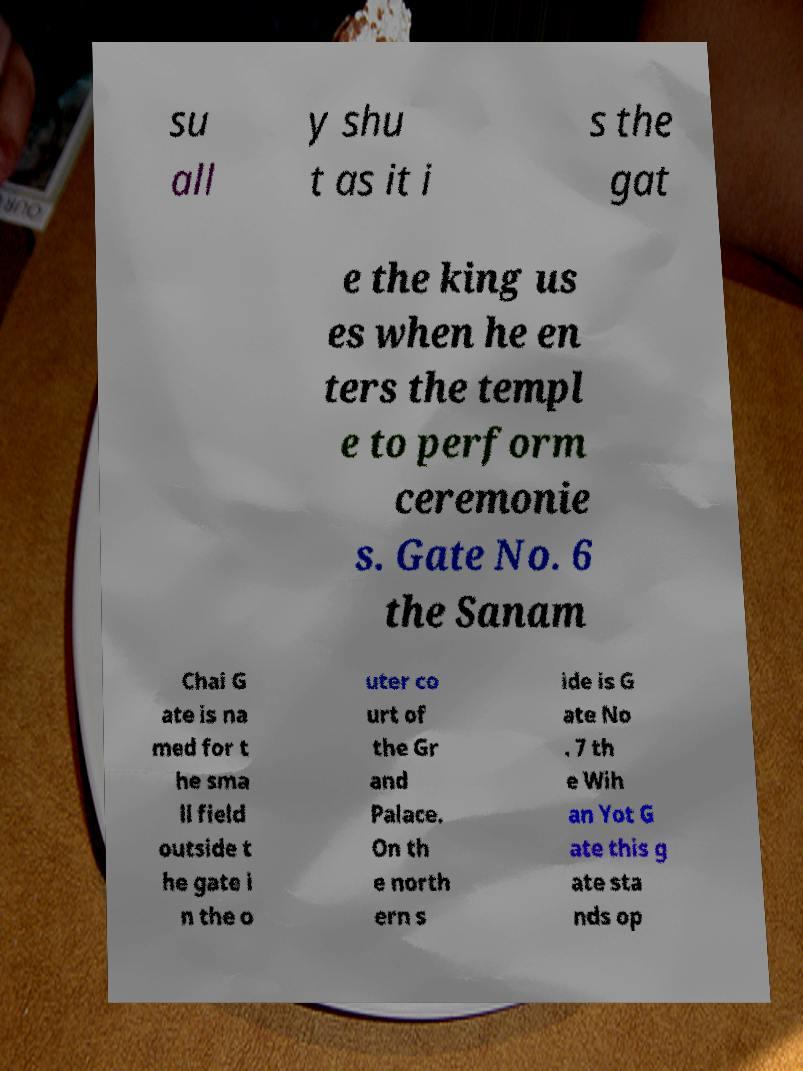What messages or text are displayed in this image? I need them in a readable, typed format. su all y shu t as it i s the gat e the king us es when he en ters the templ e to perform ceremonie s. Gate No. 6 the Sanam Chai G ate is na med for t he sma ll field outside t he gate i n the o uter co urt of the Gr and Palace. On th e north ern s ide is G ate No . 7 th e Wih an Yot G ate this g ate sta nds op 